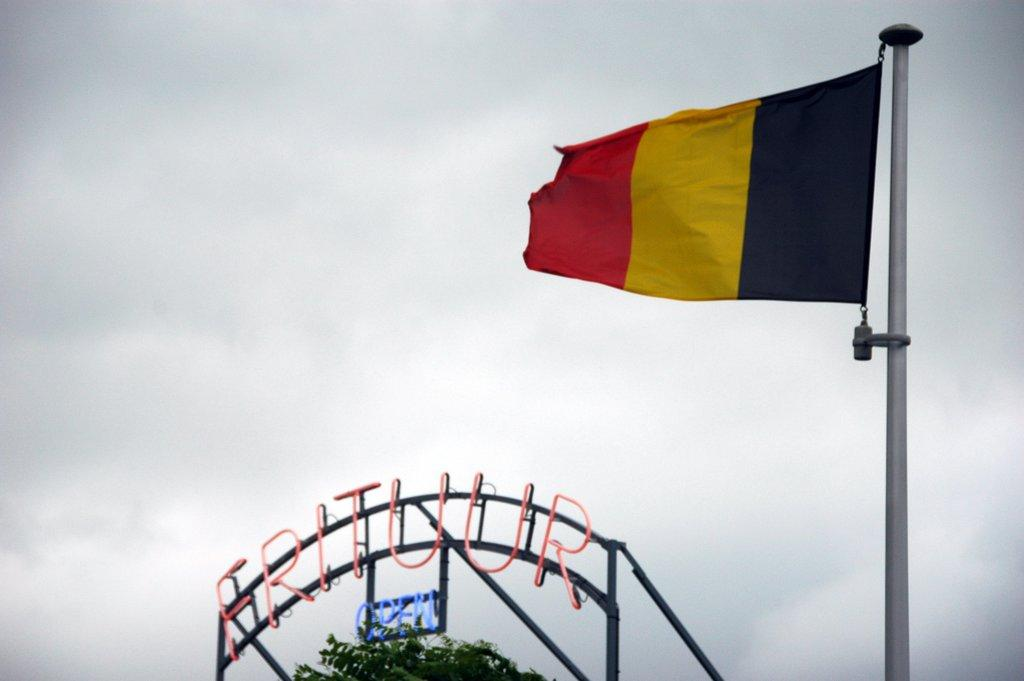What is located at the bottom of the image? There is a name board at the bottom of the image. Where is the flag positioned in the image? The flag is on the right side of the image. What can be seen in the background of the image? There is a sky visible in the background of the image. What type of spade is being used to dig in the image? There is no spade present in the image. How many coils of wire can be seen in the image? There are no coils of wire present in the image. 